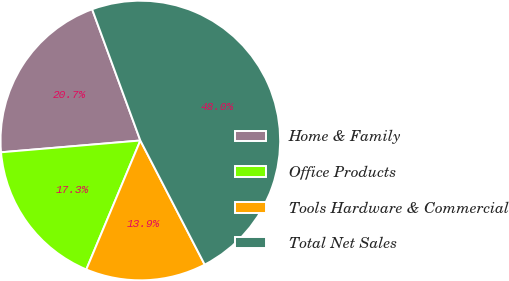Convert chart. <chart><loc_0><loc_0><loc_500><loc_500><pie_chart><fcel>Home & Family<fcel>Office Products<fcel>Tools Hardware & Commercial<fcel>Total Net Sales<nl><fcel>20.74%<fcel>17.34%<fcel>13.93%<fcel>47.99%<nl></chart> 